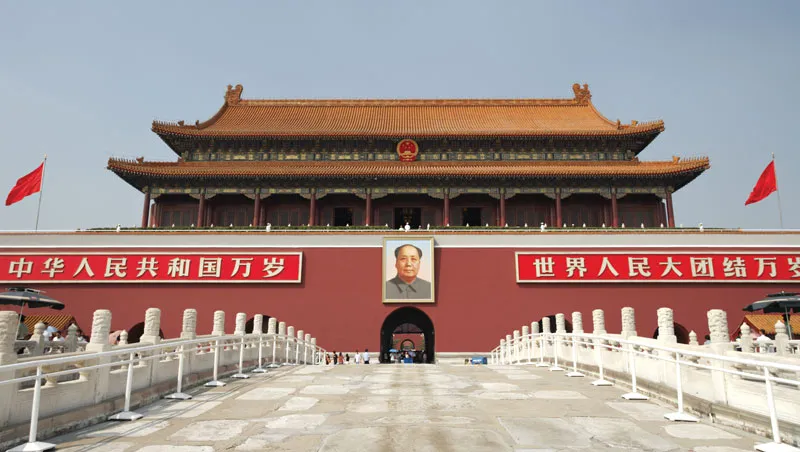Can you explain the historical significance of the portrait seen in this image? The large portrait featured in this image is of Mao Zedong, a founding figure of the People's Republic of China. His image here at Tiananmen Gate is highly symbolic, representing his role in modern Chinese political history. This portrait is a familiar sight during national celebrations and a reminder of the era of transformation that he represents. Mao's leadership during the founding of the People's Republic in 1949 and his vision for China are central to understanding the country's mid-20th century history and its ongoing political identity. 